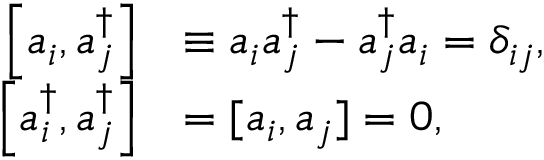Convert formula to latex. <formula><loc_0><loc_0><loc_500><loc_500>{ \begin{array} { r l } { \left [ a _ { i } ^ { \, } , a _ { j } ^ { \dagger } \right ] } & { \equiv a _ { i } ^ { \, } a _ { j } ^ { \dagger } - a _ { j } ^ { \dagger } a _ { i } ^ { \, } = \delta _ { i j } , } \\ { \left [ a _ { i } ^ { \dagger } , a _ { j } ^ { \dagger } \right ] } & { = [ a _ { i } ^ { \, } , a _ { j } ^ { \, } ] = 0 , } \end{array} }</formula> 